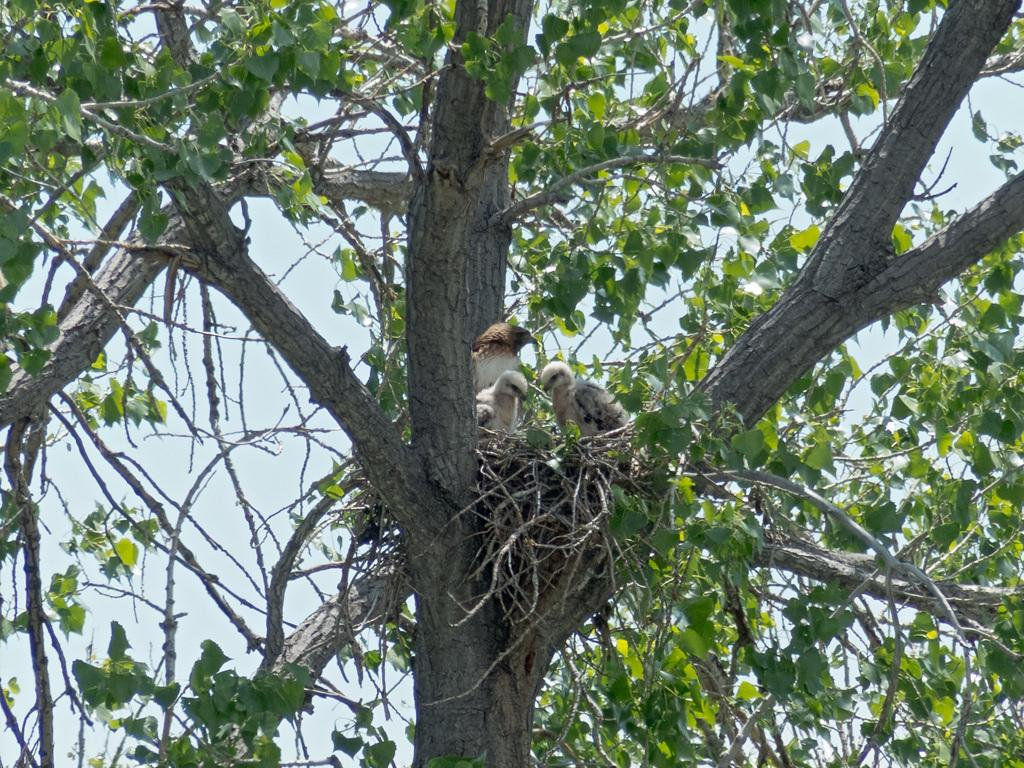What type of animals can be seen in the image? There are birds in the image. What are the birds doing in the image? The birds are around a nest in the image. Where is the nest located in the image? The nest is placed on the branches of a tree in the image. What can be seen in the background of the image? The sky is visible in the background of the image. How would you describe the weather based on the appearance of the sky? The sky looks cloudy in the image. What type of battle is taking place in the image? There is no battle present in the image; it features birds around a nest on a tree branch. Who is the creator of the birds in the image? The image does not provide information about the creator of the birds; it simply shows them in their natural environment. 